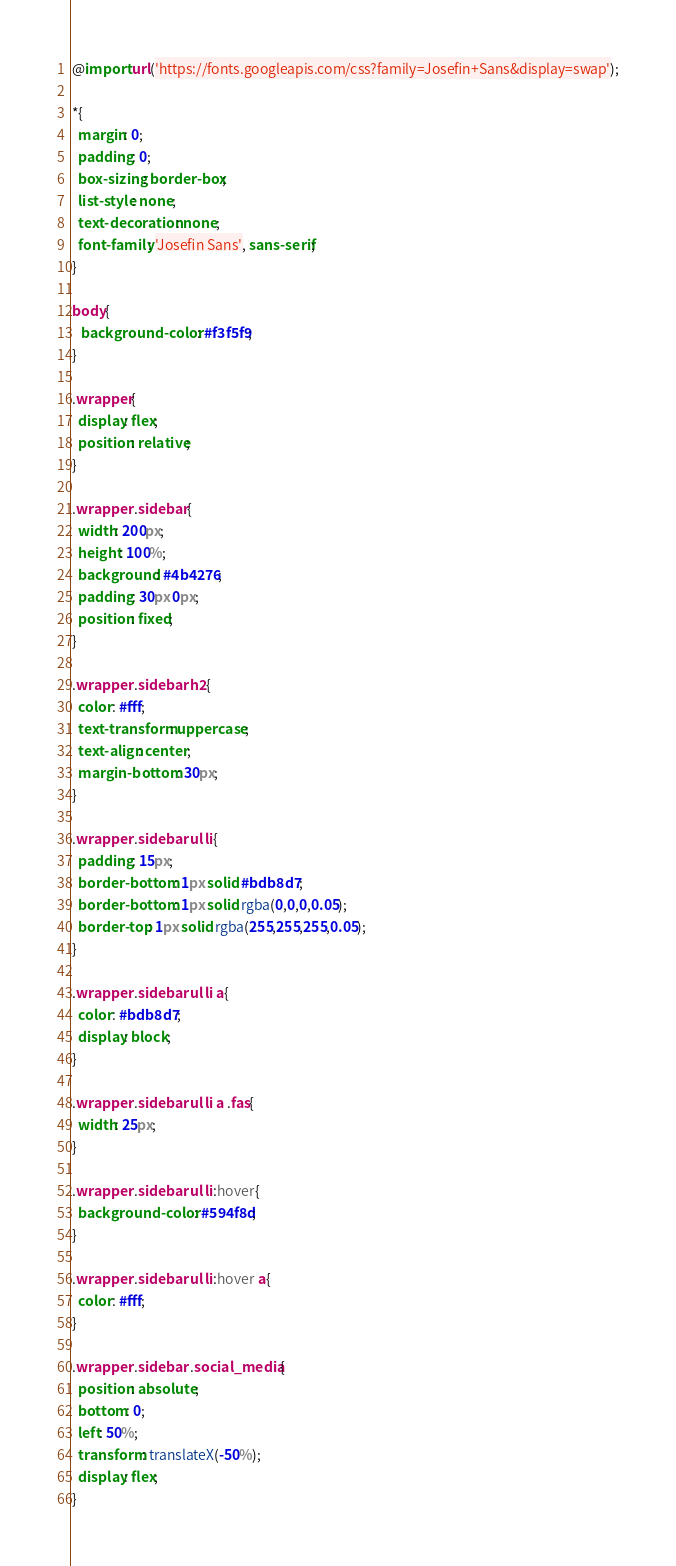Convert code to text. <code><loc_0><loc_0><loc_500><loc_500><_CSS_>@import url('https://fonts.googleapis.com/css?family=Josefin+Sans&display=swap');

*{
  margin: 0;
  padding: 0;
  box-sizing: border-box;
  list-style: none;
  text-decoration: none;
  font-family: 'Josefin Sans', sans-serif;
}

body{
   background-color: #f3f5f9;
}

.wrapper{
  display: flex;
  position: relative;
}

.wrapper .sidebar{
  width: 200px;
  height: 100%;
  background: #4b4276;
  padding: 30px 0px;
  position: fixed;
}

.wrapper .sidebar h2{
  color: #fff;
  text-transform: uppercase;
  text-align: center;
  margin-bottom: 30px;
}

.wrapper .sidebar ul li{
  padding: 15px;
  border-bottom: 1px solid #bdb8d7;
  border-bottom: 1px solid rgba(0,0,0,0.05);
  border-top: 1px solid rgba(255,255,255,0.05);
}    

.wrapper .sidebar ul li a{
  color: #bdb8d7;
  display: block;
}

.wrapper .sidebar ul li a .fas{
  width: 25px;
}

.wrapper .sidebar ul li:hover{
  background-color: #594f8d;
}

.wrapper .sidebar ul li:hover a{
  color: #fff;
}
 
.wrapper .sidebar .social_media{
  position: absolute;
  bottom: 0;
  left: 50%;
  transform: translateX(-50%);
  display: flex;
}
</code> 